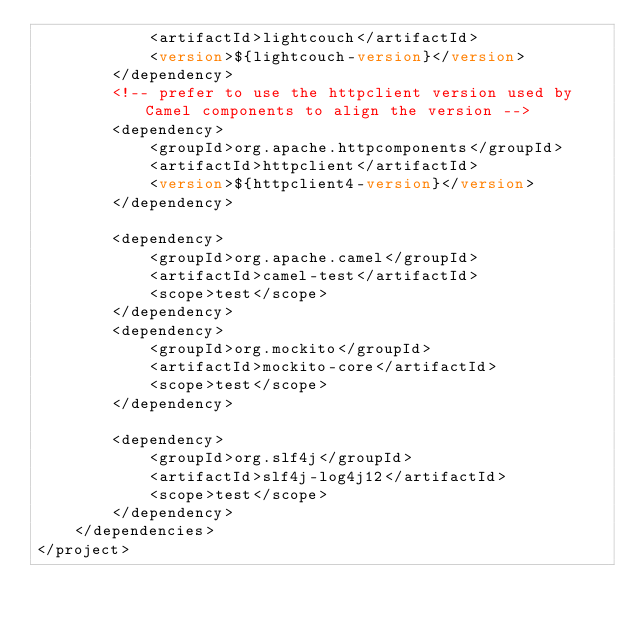<code> <loc_0><loc_0><loc_500><loc_500><_XML_>			<artifactId>lightcouch</artifactId>
			<version>${lightcouch-version}</version>
		</dependency>
		<!-- prefer to use the httpclient version used by Camel components to align the version -->
		<dependency>
			<groupId>org.apache.httpcomponents</groupId>
			<artifactId>httpclient</artifactId>
			<version>${httpclient4-version}</version>
		</dependency>

		<dependency>
			<groupId>org.apache.camel</groupId>
			<artifactId>camel-test</artifactId>
			<scope>test</scope>
		</dependency>
		<dependency>
			<groupId>org.mockito</groupId>
			<artifactId>mockito-core</artifactId>
			<scope>test</scope>
		</dependency>

		<dependency>
			<groupId>org.slf4j</groupId>
			<artifactId>slf4j-log4j12</artifactId>
			<scope>test</scope>
		</dependency>
	</dependencies>
</project></code> 